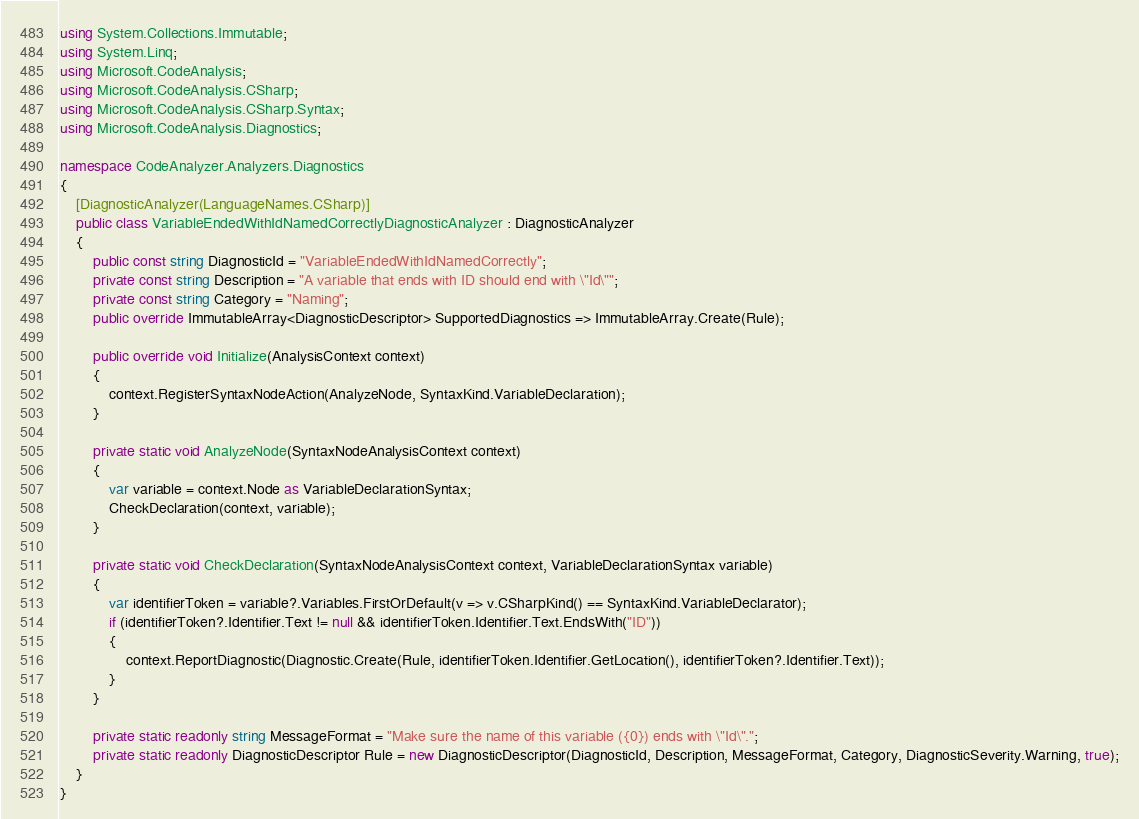<code> <loc_0><loc_0><loc_500><loc_500><_C#_>using System.Collections.Immutable;
using System.Linq;
using Microsoft.CodeAnalysis;
using Microsoft.CodeAnalysis.CSharp;
using Microsoft.CodeAnalysis.CSharp.Syntax;
using Microsoft.CodeAnalysis.Diagnostics;

namespace CodeAnalyzer.Analyzers.Diagnostics
{
    [DiagnosticAnalyzer(LanguageNames.CSharp)]
    public class VariableEndedWithIdNamedCorrectlyDiagnosticAnalyzer : DiagnosticAnalyzer
    {
        public const string DiagnosticId = "VariableEndedWithIdNamedCorrectly";
        private const string Description = "A variable that ends with ID should end with \"Id\"";
        private const string Category = "Naming";
        public override ImmutableArray<DiagnosticDescriptor> SupportedDiagnostics => ImmutableArray.Create(Rule);

        public override void Initialize(AnalysisContext context)
        {
            context.RegisterSyntaxNodeAction(AnalyzeNode, SyntaxKind.VariableDeclaration);
        }

        private static void AnalyzeNode(SyntaxNodeAnalysisContext context)
        {
            var variable = context.Node as VariableDeclarationSyntax;
            CheckDeclaration(context, variable);
        }

        private static void CheckDeclaration(SyntaxNodeAnalysisContext context, VariableDeclarationSyntax variable)
        {
            var identifierToken = variable?.Variables.FirstOrDefault(v => v.CSharpKind() == SyntaxKind.VariableDeclarator);
            if (identifierToken?.Identifier.Text != null && identifierToken.Identifier.Text.EndsWith("ID"))
            {
                context.ReportDiagnostic(Diagnostic.Create(Rule, identifierToken.Identifier.GetLocation(), identifierToken?.Identifier.Text));
            }
        }

        private static readonly string MessageFormat = "Make sure the name of this variable ({0}) ends with \"Id\".";
        private static readonly DiagnosticDescriptor Rule = new DiagnosticDescriptor(DiagnosticId, Description, MessageFormat, Category, DiagnosticSeverity.Warning, true);
    }
}</code> 